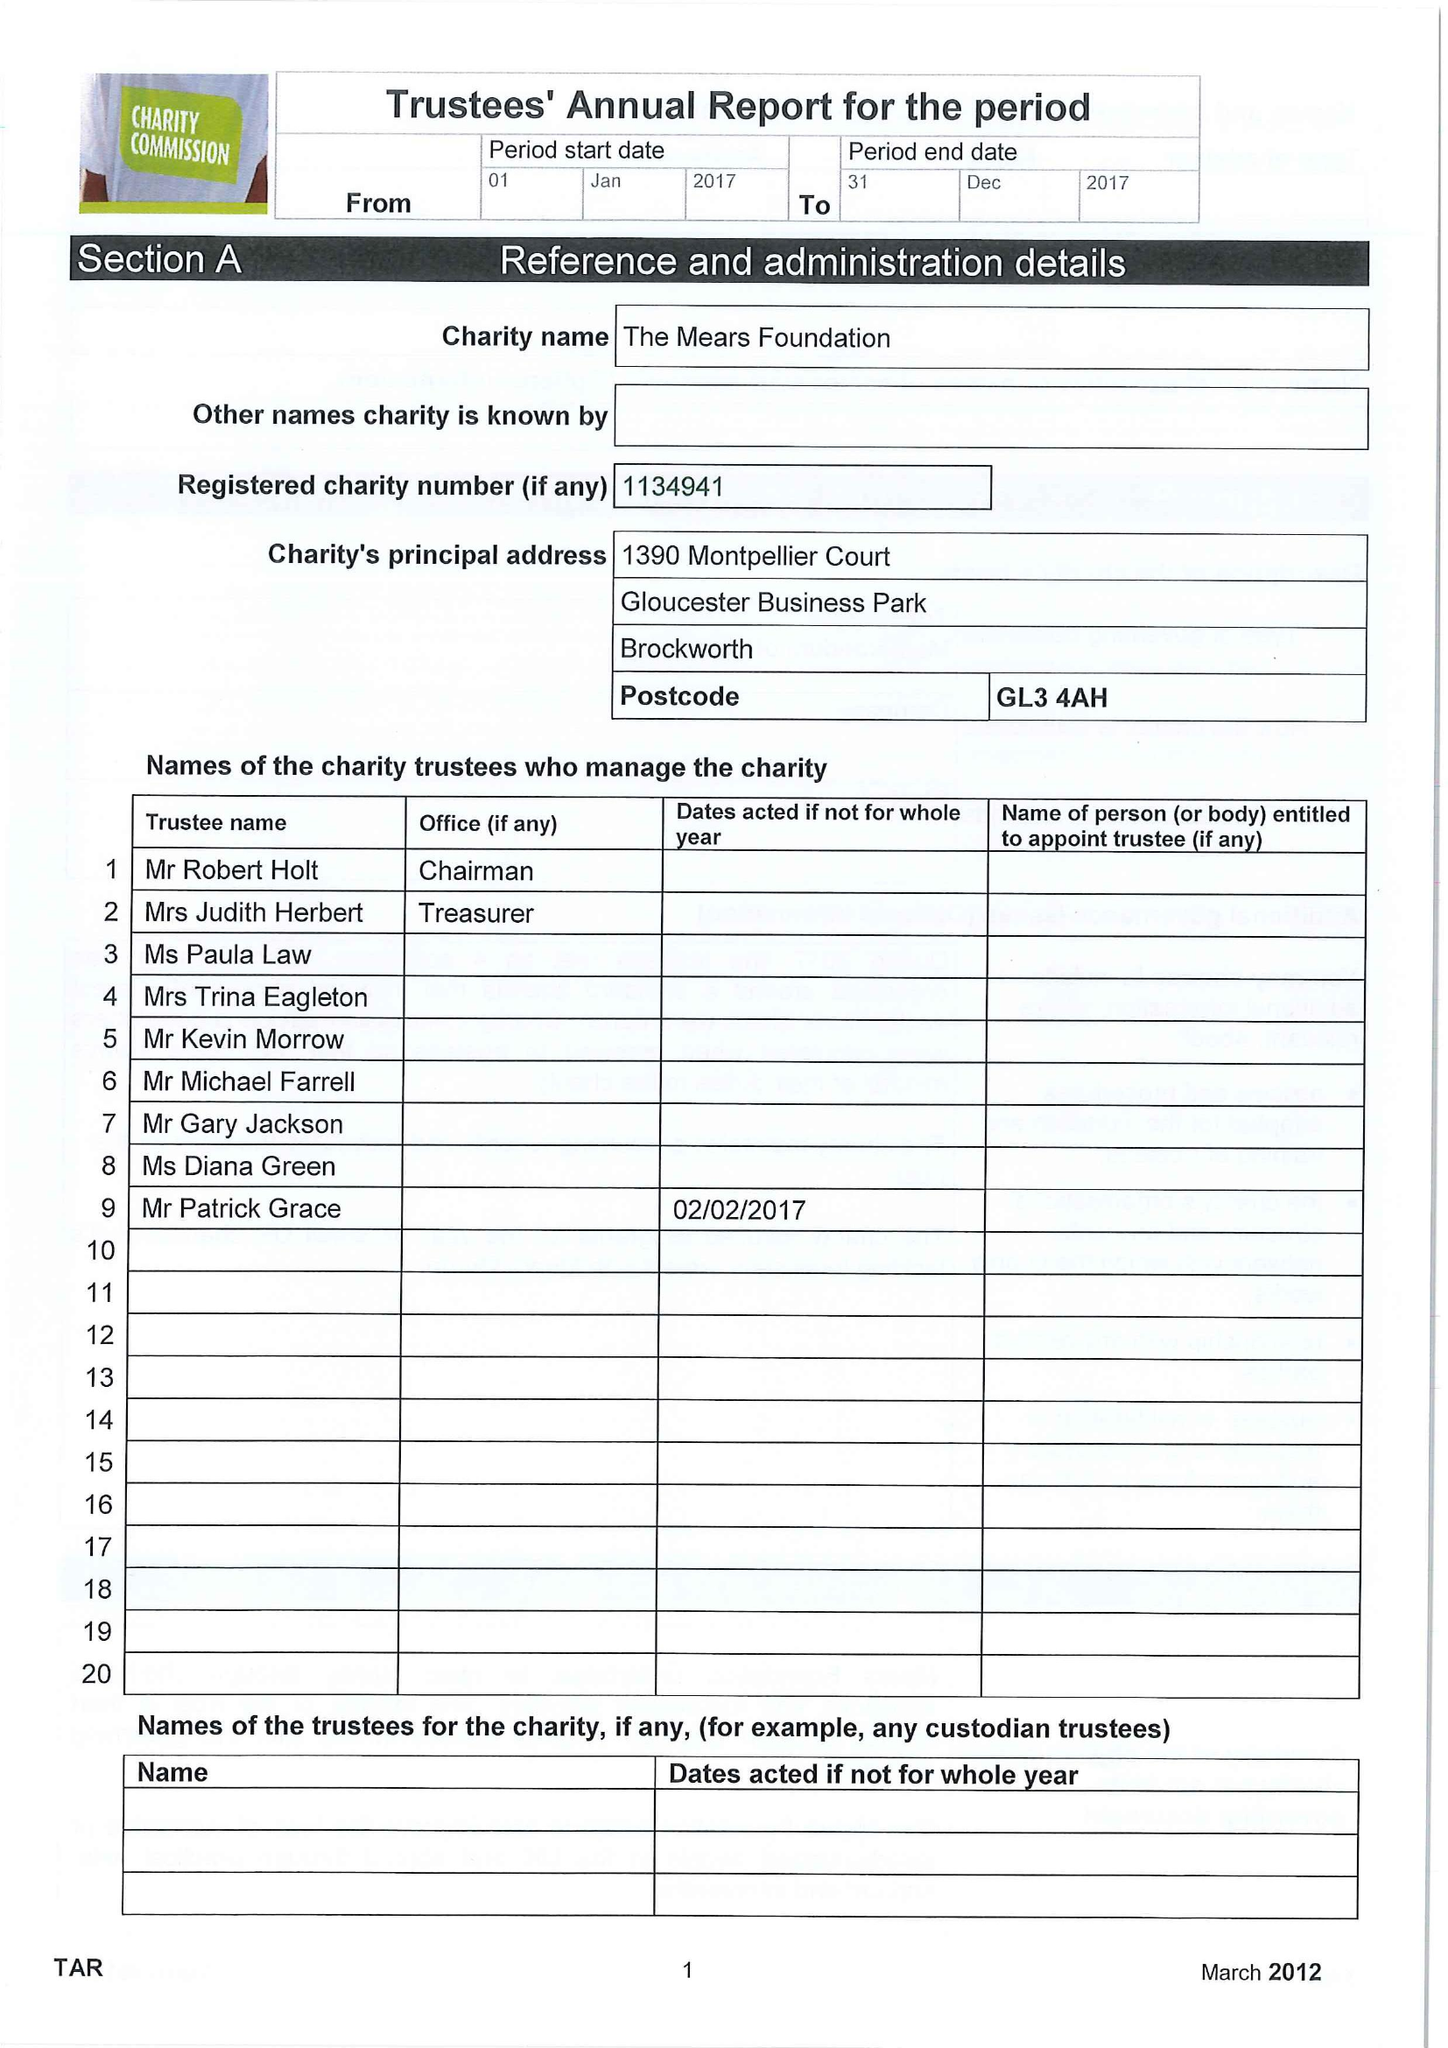What is the value for the address__street_line?
Answer the question using a single word or phrase. None 